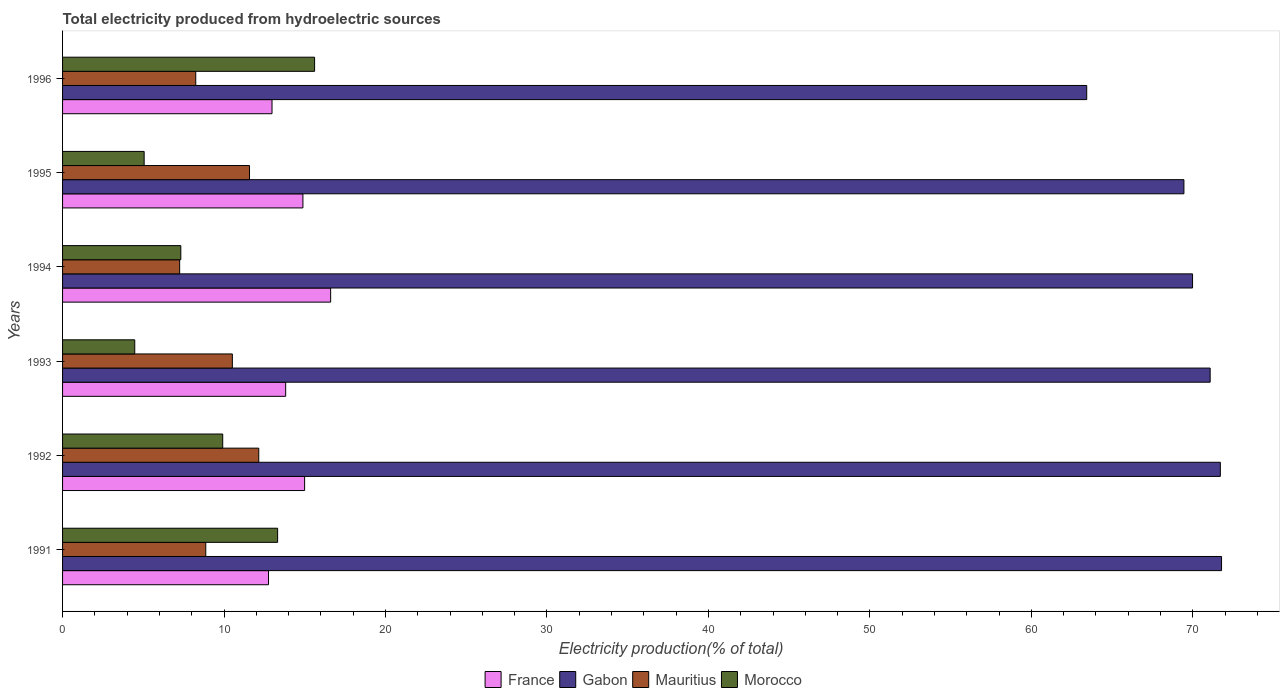How many different coloured bars are there?
Offer a terse response. 4. How many groups of bars are there?
Give a very brief answer. 6. Are the number of bars on each tick of the Y-axis equal?
Offer a terse response. Yes. How many bars are there on the 5th tick from the top?
Your response must be concise. 4. How many bars are there on the 3rd tick from the bottom?
Offer a terse response. 4. What is the total electricity produced in Mauritius in 1995?
Your answer should be compact. 11.58. Across all years, what is the maximum total electricity produced in Gabon?
Provide a short and direct response. 71.78. Across all years, what is the minimum total electricity produced in Morocco?
Keep it short and to the point. 4.47. In which year was the total electricity produced in France maximum?
Your response must be concise. 1994. What is the total total electricity produced in Morocco in the graph?
Offer a terse response. 55.69. What is the difference between the total electricity produced in Gabon in 1994 and that in 1995?
Offer a very short reply. 0.53. What is the difference between the total electricity produced in Morocco in 1994 and the total electricity produced in Gabon in 1991?
Your answer should be compact. -64.45. What is the average total electricity produced in Gabon per year?
Provide a succinct answer. 69.57. In the year 1994, what is the difference between the total electricity produced in Morocco and total electricity produced in Gabon?
Provide a succinct answer. -62.66. What is the ratio of the total electricity produced in Mauritius in 1991 to that in 1995?
Give a very brief answer. 0.77. Is the total electricity produced in Mauritius in 1994 less than that in 1995?
Make the answer very short. Yes. Is the difference between the total electricity produced in Morocco in 1992 and 1995 greater than the difference between the total electricity produced in Gabon in 1992 and 1995?
Make the answer very short. Yes. What is the difference between the highest and the second highest total electricity produced in France?
Make the answer very short. 1.61. What is the difference between the highest and the lowest total electricity produced in Gabon?
Provide a succinct answer. 8.35. Is the sum of the total electricity produced in Mauritius in 1991 and 1994 greater than the maximum total electricity produced in Gabon across all years?
Offer a very short reply. No. What does the 4th bar from the top in 1995 represents?
Offer a very short reply. France. What does the 4th bar from the bottom in 1996 represents?
Your answer should be compact. Morocco. Is it the case that in every year, the sum of the total electricity produced in Morocco and total electricity produced in Gabon is greater than the total electricity produced in Mauritius?
Your answer should be compact. Yes. Are all the bars in the graph horizontal?
Keep it short and to the point. Yes. Does the graph contain any zero values?
Make the answer very short. No. Does the graph contain grids?
Keep it short and to the point. No. Where does the legend appear in the graph?
Keep it short and to the point. Bottom center. What is the title of the graph?
Ensure brevity in your answer.  Total electricity produced from hydroelectric sources. What is the label or title of the X-axis?
Make the answer very short. Electricity production(% of total). What is the Electricity production(% of total) in France in 1991?
Your answer should be very brief. 12.75. What is the Electricity production(% of total) in Gabon in 1991?
Keep it short and to the point. 71.78. What is the Electricity production(% of total) in Mauritius in 1991?
Keep it short and to the point. 8.87. What is the Electricity production(% of total) of Morocco in 1991?
Provide a short and direct response. 13.32. What is the Electricity production(% of total) in France in 1992?
Provide a short and direct response. 14.99. What is the Electricity production(% of total) in Gabon in 1992?
Provide a succinct answer. 71.7. What is the Electricity production(% of total) of Mauritius in 1992?
Provide a short and direct response. 12.15. What is the Electricity production(% of total) of Morocco in 1992?
Your response must be concise. 9.92. What is the Electricity production(% of total) in France in 1993?
Give a very brief answer. 13.82. What is the Electricity production(% of total) in Gabon in 1993?
Provide a short and direct response. 71.07. What is the Electricity production(% of total) in Mauritius in 1993?
Ensure brevity in your answer.  10.52. What is the Electricity production(% of total) of Morocco in 1993?
Keep it short and to the point. 4.47. What is the Electricity production(% of total) in France in 1994?
Provide a short and direct response. 16.6. What is the Electricity production(% of total) in Gabon in 1994?
Offer a very short reply. 69.98. What is the Electricity production(% of total) in Mauritius in 1994?
Your answer should be very brief. 7.25. What is the Electricity production(% of total) of Morocco in 1994?
Provide a short and direct response. 7.32. What is the Electricity production(% of total) of France in 1995?
Keep it short and to the point. 14.89. What is the Electricity production(% of total) in Gabon in 1995?
Your response must be concise. 69.45. What is the Electricity production(% of total) in Mauritius in 1995?
Your response must be concise. 11.58. What is the Electricity production(% of total) of Morocco in 1995?
Keep it short and to the point. 5.05. What is the Electricity production(% of total) in France in 1996?
Ensure brevity in your answer.  12.97. What is the Electricity production(% of total) in Gabon in 1996?
Provide a succinct answer. 63.43. What is the Electricity production(% of total) of Mauritius in 1996?
Provide a short and direct response. 8.25. What is the Electricity production(% of total) in Morocco in 1996?
Offer a terse response. 15.61. Across all years, what is the maximum Electricity production(% of total) of France?
Offer a very short reply. 16.6. Across all years, what is the maximum Electricity production(% of total) in Gabon?
Provide a succinct answer. 71.78. Across all years, what is the maximum Electricity production(% of total) in Mauritius?
Your answer should be compact. 12.15. Across all years, what is the maximum Electricity production(% of total) of Morocco?
Provide a short and direct response. 15.61. Across all years, what is the minimum Electricity production(% of total) in France?
Keep it short and to the point. 12.75. Across all years, what is the minimum Electricity production(% of total) in Gabon?
Provide a short and direct response. 63.43. Across all years, what is the minimum Electricity production(% of total) in Mauritius?
Offer a very short reply. 7.25. Across all years, what is the minimum Electricity production(% of total) of Morocco?
Your answer should be very brief. 4.47. What is the total Electricity production(% of total) in France in the graph?
Provide a succinct answer. 86.02. What is the total Electricity production(% of total) of Gabon in the graph?
Provide a succinct answer. 417.4. What is the total Electricity production(% of total) of Mauritius in the graph?
Your response must be concise. 58.61. What is the total Electricity production(% of total) in Morocco in the graph?
Your response must be concise. 55.69. What is the difference between the Electricity production(% of total) in France in 1991 and that in 1992?
Offer a terse response. -2.24. What is the difference between the Electricity production(% of total) in Gabon in 1991 and that in 1992?
Your answer should be very brief. 0.07. What is the difference between the Electricity production(% of total) of Mauritius in 1991 and that in 1992?
Provide a succinct answer. -3.28. What is the difference between the Electricity production(% of total) of Morocco in 1991 and that in 1992?
Provide a succinct answer. 3.4. What is the difference between the Electricity production(% of total) in France in 1991 and that in 1993?
Provide a succinct answer. -1.06. What is the difference between the Electricity production(% of total) in Gabon in 1991 and that in 1993?
Provide a short and direct response. 0.71. What is the difference between the Electricity production(% of total) of Mauritius in 1991 and that in 1993?
Your answer should be very brief. -1.65. What is the difference between the Electricity production(% of total) of Morocco in 1991 and that in 1993?
Your response must be concise. 8.85. What is the difference between the Electricity production(% of total) of France in 1991 and that in 1994?
Give a very brief answer. -3.85. What is the difference between the Electricity production(% of total) in Gabon in 1991 and that in 1994?
Ensure brevity in your answer.  1.8. What is the difference between the Electricity production(% of total) in Mauritius in 1991 and that in 1994?
Provide a succinct answer. 1.62. What is the difference between the Electricity production(% of total) in Morocco in 1991 and that in 1994?
Your answer should be compact. 6. What is the difference between the Electricity production(% of total) of France in 1991 and that in 1995?
Make the answer very short. -2.13. What is the difference between the Electricity production(% of total) in Gabon in 1991 and that in 1995?
Your answer should be compact. 2.33. What is the difference between the Electricity production(% of total) in Mauritius in 1991 and that in 1995?
Offer a terse response. -2.71. What is the difference between the Electricity production(% of total) of Morocco in 1991 and that in 1995?
Give a very brief answer. 8.27. What is the difference between the Electricity production(% of total) in France in 1991 and that in 1996?
Make the answer very short. -0.22. What is the difference between the Electricity production(% of total) in Gabon in 1991 and that in 1996?
Ensure brevity in your answer.  8.35. What is the difference between the Electricity production(% of total) in Mauritius in 1991 and that in 1996?
Ensure brevity in your answer.  0.62. What is the difference between the Electricity production(% of total) of Morocco in 1991 and that in 1996?
Ensure brevity in your answer.  -2.29. What is the difference between the Electricity production(% of total) in France in 1992 and that in 1993?
Offer a very short reply. 1.17. What is the difference between the Electricity production(% of total) of Gabon in 1992 and that in 1993?
Offer a very short reply. 0.63. What is the difference between the Electricity production(% of total) of Mauritius in 1992 and that in 1993?
Your response must be concise. 1.63. What is the difference between the Electricity production(% of total) of Morocco in 1992 and that in 1993?
Ensure brevity in your answer.  5.45. What is the difference between the Electricity production(% of total) of France in 1992 and that in 1994?
Your answer should be very brief. -1.61. What is the difference between the Electricity production(% of total) of Gabon in 1992 and that in 1994?
Your answer should be very brief. 1.72. What is the difference between the Electricity production(% of total) in Mauritius in 1992 and that in 1994?
Offer a terse response. 4.9. What is the difference between the Electricity production(% of total) in Morocco in 1992 and that in 1994?
Your response must be concise. 2.6. What is the difference between the Electricity production(% of total) in France in 1992 and that in 1995?
Your response must be concise. 0.1. What is the difference between the Electricity production(% of total) in Gabon in 1992 and that in 1995?
Make the answer very short. 2.25. What is the difference between the Electricity production(% of total) in Mauritius in 1992 and that in 1995?
Offer a terse response. 0.57. What is the difference between the Electricity production(% of total) in Morocco in 1992 and that in 1995?
Your answer should be very brief. 4.87. What is the difference between the Electricity production(% of total) of France in 1992 and that in 1996?
Provide a short and direct response. 2.02. What is the difference between the Electricity production(% of total) of Gabon in 1992 and that in 1996?
Your response must be concise. 8.28. What is the difference between the Electricity production(% of total) in Mauritius in 1992 and that in 1996?
Ensure brevity in your answer.  3.9. What is the difference between the Electricity production(% of total) in Morocco in 1992 and that in 1996?
Keep it short and to the point. -5.69. What is the difference between the Electricity production(% of total) in France in 1993 and that in 1994?
Offer a terse response. -2.78. What is the difference between the Electricity production(% of total) in Gabon in 1993 and that in 1994?
Your response must be concise. 1.09. What is the difference between the Electricity production(% of total) in Mauritius in 1993 and that in 1994?
Provide a succinct answer. 3.26. What is the difference between the Electricity production(% of total) of Morocco in 1993 and that in 1994?
Your answer should be very brief. -2.85. What is the difference between the Electricity production(% of total) of France in 1993 and that in 1995?
Your answer should be very brief. -1.07. What is the difference between the Electricity production(% of total) in Gabon in 1993 and that in 1995?
Give a very brief answer. 1.62. What is the difference between the Electricity production(% of total) in Mauritius in 1993 and that in 1995?
Your answer should be very brief. -1.06. What is the difference between the Electricity production(% of total) of Morocco in 1993 and that in 1995?
Keep it short and to the point. -0.58. What is the difference between the Electricity production(% of total) of France in 1993 and that in 1996?
Keep it short and to the point. 0.85. What is the difference between the Electricity production(% of total) in Gabon in 1993 and that in 1996?
Your answer should be compact. 7.64. What is the difference between the Electricity production(% of total) in Mauritius in 1993 and that in 1996?
Your answer should be compact. 2.27. What is the difference between the Electricity production(% of total) in Morocco in 1993 and that in 1996?
Offer a very short reply. -11.14. What is the difference between the Electricity production(% of total) of France in 1994 and that in 1995?
Your response must be concise. 1.72. What is the difference between the Electricity production(% of total) of Gabon in 1994 and that in 1995?
Offer a terse response. 0.53. What is the difference between the Electricity production(% of total) in Mauritius in 1994 and that in 1995?
Make the answer very short. -4.33. What is the difference between the Electricity production(% of total) of Morocco in 1994 and that in 1995?
Offer a very short reply. 2.27. What is the difference between the Electricity production(% of total) of France in 1994 and that in 1996?
Make the answer very short. 3.63. What is the difference between the Electricity production(% of total) of Gabon in 1994 and that in 1996?
Offer a terse response. 6.55. What is the difference between the Electricity production(% of total) in Mauritius in 1994 and that in 1996?
Your answer should be compact. -1. What is the difference between the Electricity production(% of total) in Morocco in 1994 and that in 1996?
Your answer should be very brief. -8.29. What is the difference between the Electricity production(% of total) in France in 1995 and that in 1996?
Provide a succinct answer. 1.91. What is the difference between the Electricity production(% of total) of Gabon in 1995 and that in 1996?
Offer a terse response. 6.02. What is the difference between the Electricity production(% of total) in Mauritius in 1995 and that in 1996?
Offer a very short reply. 3.33. What is the difference between the Electricity production(% of total) in Morocco in 1995 and that in 1996?
Keep it short and to the point. -10.56. What is the difference between the Electricity production(% of total) of France in 1991 and the Electricity production(% of total) of Gabon in 1992?
Give a very brief answer. -58.95. What is the difference between the Electricity production(% of total) of France in 1991 and the Electricity production(% of total) of Mauritius in 1992?
Provide a succinct answer. 0.6. What is the difference between the Electricity production(% of total) in France in 1991 and the Electricity production(% of total) in Morocco in 1992?
Keep it short and to the point. 2.84. What is the difference between the Electricity production(% of total) in Gabon in 1991 and the Electricity production(% of total) in Mauritius in 1992?
Make the answer very short. 59.63. What is the difference between the Electricity production(% of total) in Gabon in 1991 and the Electricity production(% of total) in Morocco in 1992?
Keep it short and to the point. 61.86. What is the difference between the Electricity production(% of total) in Mauritius in 1991 and the Electricity production(% of total) in Morocco in 1992?
Provide a short and direct response. -1.05. What is the difference between the Electricity production(% of total) in France in 1991 and the Electricity production(% of total) in Gabon in 1993?
Give a very brief answer. -58.32. What is the difference between the Electricity production(% of total) of France in 1991 and the Electricity production(% of total) of Mauritius in 1993?
Your answer should be compact. 2.24. What is the difference between the Electricity production(% of total) in France in 1991 and the Electricity production(% of total) in Morocco in 1993?
Offer a terse response. 8.28. What is the difference between the Electricity production(% of total) in Gabon in 1991 and the Electricity production(% of total) in Mauritius in 1993?
Your response must be concise. 61.26. What is the difference between the Electricity production(% of total) in Gabon in 1991 and the Electricity production(% of total) in Morocco in 1993?
Your response must be concise. 67.31. What is the difference between the Electricity production(% of total) of Mauritius in 1991 and the Electricity production(% of total) of Morocco in 1993?
Provide a short and direct response. 4.4. What is the difference between the Electricity production(% of total) of France in 1991 and the Electricity production(% of total) of Gabon in 1994?
Make the answer very short. -57.23. What is the difference between the Electricity production(% of total) in France in 1991 and the Electricity production(% of total) in Mauritius in 1994?
Make the answer very short. 5.5. What is the difference between the Electricity production(% of total) of France in 1991 and the Electricity production(% of total) of Morocco in 1994?
Offer a very short reply. 5.43. What is the difference between the Electricity production(% of total) of Gabon in 1991 and the Electricity production(% of total) of Mauritius in 1994?
Give a very brief answer. 64.52. What is the difference between the Electricity production(% of total) in Gabon in 1991 and the Electricity production(% of total) in Morocco in 1994?
Your response must be concise. 64.45. What is the difference between the Electricity production(% of total) in Mauritius in 1991 and the Electricity production(% of total) in Morocco in 1994?
Offer a very short reply. 1.54. What is the difference between the Electricity production(% of total) of France in 1991 and the Electricity production(% of total) of Gabon in 1995?
Make the answer very short. -56.69. What is the difference between the Electricity production(% of total) in France in 1991 and the Electricity production(% of total) in Mauritius in 1995?
Offer a very short reply. 1.18. What is the difference between the Electricity production(% of total) in France in 1991 and the Electricity production(% of total) in Morocco in 1995?
Keep it short and to the point. 7.7. What is the difference between the Electricity production(% of total) of Gabon in 1991 and the Electricity production(% of total) of Mauritius in 1995?
Provide a succinct answer. 60.2. What is the difference between the Electricity production(% of total) of Gabon in 1991 and the Electricity production(% of total) of Morocco in 1995?
Offer a very short reply. 66.72. What is the difference between the Electricity production(% of total) in Mauritius in 1991 and the Electricity production(% of total) in Morocco in 1995?
Provide a short and direct response. 3.82. What is the difference between the Electricity production(% of total) in France in 1991 and the Electricity production(% of total) in Gabon in 1996?
Your response must be concise. -50.67. What is the difference between the Electricity production(% of total) of France in 1991 and the Electricity production(% of total) of Mauritius in 1996?
Provide a succinct answer. 4.51. What is the difference between the Electricity production(% of total) of France in 1991 and the Electricity production(% of total) of Morocco in 1996?
Provide a succinct answer. -2.85. What is the difference between the Electricity production(% of total) in Gabon in 1991 and the Electricity production(% of total) in Mauritius in 1996?
Your answer should be compact. 63.53. What is the difference between the Electricity production(% of total) of Gabon in 1991 and the Electricity production(% of total) of Morocco in 1996?
Keep it short and to the point. 56.17. What is the difference between the Electricity production(% of total) in Mauritius in 1991 and the Electricity production(% of total) in Morocco in 1996?
Provide a succinct answer. -6.74. What is the difference between the Electricity production(% of total) of France in 1992 and the Electricity production(% of total) of Gabon in 1993?
Offer a very short reply. -56.08. What is the difference between the Electricity production(% of total) in France in 1992 and the Electricity production(% of total) in Mauritius in 1993?
Your answer should be compact. 4.47. What is the difference between the Electricity production(% of total) of France in 1992 and the Electricity production(% of total) of Morocco in 1993?
Keep it short and to the point. 10.52. What is the difference between the Electricity production(% of total) of Gabon in 1992 and the Electricity production(% of total) of Mauritius in 1993?
Offer a very short reply. 61.19. What is the difference between the Electricity production(% of total) in Gabon in 1992 and the Electricity production(% of total) in Morocco in 1993?
Offer a very short reply. 67.23. What is the difference between the Electricity production(% of total) in Mauritius in 1992 and the Electricity production(% of total) in Morocco in 1993?
Give a very brief answer. 7.68. What is the difference between the Electricity production(% of total) of France in 1992 and the Electricity production(% of total) of Gabon in 1994?
Provide a short and direct response. -54.99. What is the difference between the Electricity production(% of total) of France in 1992 and the Electricity production(% of total) of Mauritius in 1994?
Your answer should be compact. 7.74. What is the difference between the Electricity production(% of total) in France in 1992 and the Electricity production(% of total) in Morocco in 1994?
Make the answer very short. 7.67. What is the difference between the Electricity production(% of total) of Gabon in 1992 and the Electricity production(% of total) of Mauritius in 1994?
Offer a terse response. 64.45. What is the difference between the Electricity production(% of total) of Gabon in 1992 and the Electricity production(% of total) of Morocco in 1994?
Ensure brevity in your answer.  64.38. What is the difference between the Electricity production(% of total) in Mauritius in 1992 and the Electricity production(% of total) in Morocco in 1994?
Your response must be concise. 4.83. What is the difference between the Electricity production(% of total) of France in 1992 and the Electricity production(% of total) of Gabon in 1995?
Keep it short and to the point. -54.46. What is the difference between the Electricity production(% of total) of France in 1992 and the Electricity production(% of total) of Mauritius in 1995?
Provide a short and direct response. 3.41. What is the difference between the Electricity production(% of total) of France in 1992 and the Electricity production(% of total) of Morocco in 1995?
Offer a very short reply. 9.94. What is the difference between the Electricity production(% of total) of Gabon in 1992 and the Electricity production(% of total) of Mauritius in 1995?
Keep it short and to the point. 60.12. What is the difference between the Electricity production(% of total) of Gabon in 1992 and the Electricity production(% of total) of Morocco in 1995?
Provide a short and direct response. 66.65. What is the difference between the Electricity production(% of total) in Mauritius in 1992 and the Electricity production(% of total) in Morocco in 1995?
Provide a short and direct response. 7.1. What is the difference between the Electricity production(% of total) in France in 1992 and the Electricity production(% of total) in Gabon in 1996?
Provide a succinct answer. -48.44. What is the difference between the Electricity production(% of total) of France in 1992 and the Electricity production(% of total) of Mauritius in 1996?
Offer a terse response. 6.74. What is the difference between the Electricity production(% of total) of France in 1992 and the Electricity production(% of total) of Morocco in 1996?
Make the answer very short. -0.62. What is the difference between the Electricity production(% of total) in Gabon in 1992 and the Electricity production(% of total) in Mauritius in 1996?
Your answer should be compact. 63.45. What is the difference between the Electricity production(% of total) of Gabon in 1992 and the Electricity production(% of total) of Morocco in 1996?
Provide a short and direct response. 56.09. What is the difference between the Electricity production(% of total) of Mauritius in 1992 and the Electricity production(% of total) of Morocco in 1996?
Provide a short and direct response. -3.46. What is the difference between the Electricity production(% of total) of France in 1993 and the Electricity production(% of total) of Gabon in 1994?
Give a very brief answer. -56.16. What is the difference between the Electricity production(% of total) in France in 1993 and the Electricity production(% of total) in Mauritius in 1994?
Make the answer very short. 6.57. What is the difference between the Electricity production(% of total) of France in 1993 and the Electricity production(% of total) of Morocco in 1994?
Keep it short and to the point. 6.49. What is the difference between the Electricity production(% of total) in Gabon in 1993 and the Electricity production(% of total) in Mauritius in 1994?
Provide a succinct answer. 63.82. What is the difference between the Electricity production(% of total) in Gabon in 1993 and the Electricity production(% of total) in Morocco in 1994?
Offer a terse response. 63.75. What is the difference between the Electricity production(% of total) in Mauritius in 1993 and the Electricity production(% of total) in Morocco in 1994?
Provide a short and direct response. 3.19. What is the difference between the Electricity production(% of total) of France in 1993 and the Electricity production(% of total) of Gabon in 1995?
Provide a succinct answer. -55.63. What is the difference between the Electricity production(% of total) in France in 1993 and the Electricity production(% of total) in Mauritius in 1995?
Offer a very short reply. 2.24. What is the difference between the Electricity production(% of total) of France in 1993 and the Electricity production(% of total) of Morocco in 1995?
Offer a very short reply. 8.76. What is the difference between the Electricity production(% of total) in Gabon in 1993 and the Electricity production(% of total) in Mauritius in 1995?
Provide a succinct answer. 59.49. What is the difference between the Electricity production(% of total) in Gabon in 1993 and the Electricity production(% of total) in Morocco in 1995?
Offer a very short reply. 66.02. What is the difference between the Electricity production(% of total) of Mauritius in 1993 and the Electricity production(% of total) of Morocco in 1995?
Your response must be concise. 5.46. What is the difference between the Electricity production(% of total) of France in 1993 and the Electricity production(% of total) of Gabon in 1996?
Offer a terse response. -49.61. What is the difference between the Electricity production(% of total) of France in 1993 and the Electricity production(% of total) of Mauritius in 1996?
Your answer should be very brief. 5.57. What is the difference between the Electricity production(% of total) of France in 1993 and the Electricity production(% of total) of Morocco in 1996?
Ensure brevity in your answer.  -1.79. What is the difference between the Electricity production(% of total) of Gabon in 1993 and the Electricity production(% of total) of Mauritius in 1996?
Offer a terse response. 62.82. What is the difference between the Electricity production(% of total) of Gabon in 1993 and the Electricity production(% of total) of Morocco in 1996?
Offer a terse response. 55.46. What is the difference between the Electricity production(% of total) of Mauritius in 1993 and the Electricity production(% of total) of Morocco in 1996?
Provide a succinct answer. -5.09. What is the difference between the Electricity production(% of total) in France in 1994 and the Electricity production(% of total) in Gabon in 1995?
Ensure brevity in your answer.  -52.84. What is the difference between the Electricity production(% of total) in France in 1994 and the Electricity production(% of total) in Mauritius in 1995?
Provide a short and direct response. 5.02. What is the difference between the Electricity production(% of total) of France in 1994 and the Electricity production(% of total) of Morocco in 1995?
Ensure brevity in your answer.  11.55. What is the difference between the Electricity production(% of total) in Gabon in 1994 and the Electricity production(% of total) in Mauritius in 1995?
Give a very brief answer. 58.4. What is the difference between the Electricity production(% of total) in Gabon in 1994 and the Electricity production(% of total) in Morocco in 1995?
Your response must be concise. 64.93. What is the difference between the Electricity production(% of total) in Mauritius in 1994 and the Electricity production(% of total) in Morocco in 1995?
Your answer should be very brief. 2.2. What is the difference between the Electricity production(% of total) in France in 1994 and the Electricity production(% of total) in Gabon in 1996?
Give a very brief answer. -46.82. What is the difference between the Electricity production(% of total) in France in 1994 and the Electricity production(% of total) in Mauritius in 1996?
Make the answer very short. 8.35. What is the difference between the Electricity production(% of total) of Gabon in 1994 and the Electricity production(% of total) of Mauritius in 1996?
Make the answer very short. 61.73. What is the difference between the Electricity production(% of total) of Gabon in 1994 and the Electricity production(% of total) of Morocco in 1996?
Make the answer very short. 54.37. What is the difference between the Electricity production(% of total) of Mauritius in 1994 and the Electricity production(% of total) of Morocco in 1996?
Make the answer very short. -8.36. What is the difference between the Electricity production(% of total) of France in 1995 and the Electricity production(% of total) of Gabon in 1996?
Keep it short and to the point. -48.54. What is the difference between the Electricity production(% of total) in France in 1995 and the Electricity production(% of total) in Mauritius in 1996?
Offer a very short reply. 6.64. What is the difference between the Electricity production(% of total) of France in 1995 and the Electricity production(% of total) of Morocco in 1996?
Provide a succinct answer. -0.72. What is the difference between the Electricity production(% of total) of Gabon in 1995 and the Electricity production(% of total) of Mauritius in 1996?
Offer a very short reply. 61.2. What is the difference between the Electricity production(% of total) of Gabon in 1995 and the Electricity production(% of total) of Morocco in 1996?
Ensure brevity in your answer.  53.84. What is the difference between the Electricity production(% of total) in Mauritius in 1995 and the Electricity production(% of total) in Morocco in 1996?
Your answer should be compact. -4.03. What is the average Electricity production(% of total) in France per year?
Your response must be concise. 14.34. What is the average Electricity production(% of total) in Gabon per year?
Provide a short and direct response. 69.57. What is the average Electricity production(% of total) of Mauritius per year?
Make the answer very short. 9.77. What is the average Electricity production(% of total) in Morocco per year?
Your answer should be compact. 9.28. In the year 1991, what is the difference between the Electricity production(% of total) in France and Electricity production(% of total) in Gabon?
Provide a short and direct response. -59.02. In the year 1991, what is the difference between the Electricity production(% of total) of France and Electricity production(% of total) of Mauritius?
Provide a short and direct response. 3.89. In the year 1991, what is the difference between the Electricity production(% of total) of France and Electricity production(% of total) of Morocco?
Ensure brevity in your answer.  -0.56. In the year 1991, what is the difference between the Electricity production(% of total) of Gabon and Electricity production(% of total) of Mauritius?
Ensure brevity in your answer.  62.91. In the year 1991, what is the difference between the Electricity production(% of total) in Gabon and Electricity production(% of total) in Morocco?
Your answer should be very brief. 58.46. In the year 1991, what is the difference between the Electricity production(% of total) of Mauritius and Electricity production(% of total) of Morocco?
Give a very brief answer. -4.45. In the year 1992, what is the difference between the Electricity production(% of total) of France and Electricity production(% of total) of Gabon?
Give a very brief answer. -56.71. In the year 1992, what is the difference between the Electricity production(% of total) in France and Electricity production(% of total) in Mauritius?
Provide a short and direct response. 2.84. In the year 1992, what is the difference between the Electricity production(% of total) in France and Electricity production(% of total) in Morocco?
Provide a short and direct response. 5.07. In the year 1992, what is the difference between the Electricity production(% of total) in Gabon and Electricity production(% of total) in Mauritius?
Offer a very short reply. 59.55. In the year 1992, what is the difference between the Electricity production(% of total) of Gabon and Electricity production(% of total) of Morocco?
Provide a succinct answer. 61.78. In the year 1992, what is the difference between the Electricity production(% of total) in Mauritius and Electricity production(% of total) in Morocco?
Offer a terse response. 2.23. In the year 1993, what is the difference between the Electricity production(% of total) of France and Electricity production(% of total) of Gabon?
Give a very brief answer. -57.25. In the year 1993, what is the difference between the Electricity production(% of total) in France and Electricity production(% of total) in Mauritius?
Ensure brevity in your answer.  3.3. In the year 1993, what is the difference between the Electricity production(% of total) of France and Electricity production(% of total) of Morocco?
Give a very brief answer. 9.35. In the year 1993, what is the difference between the Electricity production(% of total) of Gabon and Electricity production(% of total) of Mauritius?
Provide a succinct answer. 60.56. In the year 1993, what is the difference between the Electricity production(% of total) in Gabon and Electricity production(% of total) in Morocco?
Offer a very short reply. 66.6. In the year 1993, what is the difference between the Electricity production(% of total) of Mauritius and Electricity production(% of total) of Morocco?
Give a very brief answer. 6.05. In the year 1994, what is the difference between the Electricity production(% of total) of France and Electricity production(% of total) of Gabon?
Your answer should be compact. -53.38. In the year 1994, what is the difference between the Electricity production(% of total) of France and Electricity production(% of total) of Mauritius?
Your answer should be very brief. 9.35. In the year 1994, what is the difference between the Electricity production(% of total) of France and Electricity production(% of total) of Morocco?
Offer a terse response. 9.28. In the year 1994, what is the difference between the Electricity production(% of total) in Gabon and Electricity production(% of total) in Mauritius?
Your answer should be compact. 62.73. In the year 1994, what is the difference between the Electricity production(% of total) of Gabon and Electricity production(% of total) of Morocco?
Your answer should be compact. 62.66. In the year 1994, what is the difference between the Electricity production(% of total) of Mauritius and Electricity production(% of total) of Morocco?
Keep it short and to the point. -0.07. In the year 1995, what is the difference between the Electricity production(% of total) in France and Electricity production(% of total) in Gabon?
Keep it short and to the point. -54.56. In the year 1995, what is the difference between the Electricity production(% of total) of France and Electricity production(% of total) of Mauritius?
Provide a succinct answer. 3.31. In the year 1995, what is the difference between the Electricity production(% of total) in France and Electricity production(% of total) in Morocco?
Your answer should be compact. 9.83. In the year 1995, what is the difference between the Electricity production(% of total) in Gabon and Electricity production(% of total) in Mauritius?
Make the answer very short. 57.87. In the year 1995, what is the difference between the Electricity production(% of total) of Gabon and Electricity production(% of total) of Morocco?
Provide a succinct answer. 64.39. In the year 1995, what is the difference between the Electricity production(% of total) in Mauritius and Electricity production(% of total) in Morocco?
Your response must be concise. 6.53. In the year 1996, what is the difference between the Electricity production(% of total) of France and Electricity production(% of total) of Gabon?
Give a very brief answer. -50.46. In the year 1996, what is the difference between the Electricity production(% of total) in France and Electricity production(% of total) in Mauritius?
Keep it short and to the point. 4.72. In the year 1996, what is the difference between the Electricity production(% of total) in France and Electricity production(% of total) in Morocco?
Ensure brevity in your answer.  -2.64. In the year 1996, what is the difference between the Electricity production(% of total) of Gabon and Electricity production(% of total) of Mauritius?
Your response must be concise. 55.18. In the year 1996, what is the difference between the Electricity production(% of total) in Gabon and Electricity production(% of total) in Morocco?
Offer a very short reply. 47.82. In the year 1996, what is the difference between the Electricity production(% of total) of Mauritius and Electricity production(% of total) of Morocco?
Offer a very short reply. -7.36. What is the ratio of the Electricity production(% of total) in France in 1991 to that in 1992?
Offer a very short reply. 0.85. What is the ratio of the Electricity production(% of total) of Mauritius in 1991 to that in 1992?
Offer a terse response. 0.73. What is the ratio of the Electricity production(% of total) of Morocco in 1991 to that in 1992?
Ensure brevity in your answer.  1.34. What is the ratio of the Electricity production(% of total) in Gabon in 1991 to that in 1993?
Provide a short and direct response. 1.01. What is the ratio of the Electricity production(% of total) in Mauritius in 1991 to that in 1993?
Give a very brief answer. 0.84. What is the ratio of the Electricity production(% of total) of Morocco in 1991 to that in 1993?
Offer a terse response. 2.98. What is the ratio of the Electricity production(% of total) of France in 1991 to that in 1994?
Keep it short and to the point. 0.77. What is the ratio of the Electricity production(% of total) in Gabon in 1991 to that in 1994?
Your answer should be compact. 1.03. What is the ratio of the Electricity production(% of total) in Mauritius in 1991 to that in 1994?
Keep it short and to the point. 1.22. What is the ratio of the Electricity production(% of total) in Morocco in 1991 to that in 1994?
Make the answer very short. 1.82. What is the ratio of the Electricity production(% of total) in France in 1991 to that in 1995?
Ensure brevity in your answer.  0.86. What is the ratio of the Electricity production(% of total) of Gabon in 1991 to that in 1995?
Give a very brief answer. 1.03. What is the ratio of the Electricity production(% of total) of Mauritius in 1991 to that in 1995?
Offer a terse response. 0.77. What is the ratio of the Electricity production(% of total) in Morocco in 1991 to that in 1995?
Offer a very short reply. 2.64. What is the ratio of the Electricity production(% of total) of France in 1991 to that in 1996?
Keep it short and to the point. 0.98. What is the ratio of the Electricity production(% of total) in Gabon in 1991 to that in 1996?
Offer a very short reply. 1.13. What is the ratio of the Electricity production(% of total) in Mauritius in 1991 to that in 1996?
Ensure brevity in your answer.  1.08. What is the ratio of the Electricity production(% of total) in Morocco in 1991 to that in 1996?
Provide a short and direct response. 0.85. What is the ratio of the Electricity production(% of total) in France in 1992 to that in 1993?
Your response must be concise. 1.08. What is the ratio of the Electricity production(% of total) in Gabon in 1992 to that in 1993?
Ensure brevity in your answer.  1.01. What is the ratio of the Electricity production(% of total) of Mauritius in 1992 to that in 1993?
Your answer should be very brief. 1.16. What is the ratio of the Electricity production(% of total) in Morocco in 1992 to that in 1993?
Give a very brief answer. 2.22. What is the ratio of the Electricity production(% of total) of France in 1992 to that in 1994?
Keep it short and to the point. 0.9. What is the ratio of the Electricity production(% of total) of Gabon in 1992 to that in 1994?
Your answer should be compact. 1.02. What is the ratio of the Electricity production(% of total) in Mauritius in 1992 to that in 1994?
Provide a short and direct response. 1.68. What is the ratio of the Electricity production(% of total) in Morocco in 1992 to that in 1994?
Provide a succinct answer. 1.35. What is the ratio of the Electricity production(% of total) in France in 1992 to that in 1995?
Give a very brief answer. 1.01. What is the ratio of the Electricity production(% of total) of Gabon in 1992 to that in 1995?
Provide a succinct answer. 1.03. What is the ratio of the Electricity production(% of total) of Mauritius in 1992 to that in 1995?
Your answer should be compact. 1.05. What is the ratio of the Electricity production(% of total) in Morocco in 1992 to that in 1995?
Offer a very short reply. 1.96. What is the ratio of the Electricity production(% of total) in France in 1992 to that in 1996?
Make the answer very short. 1.16. What is the ratio of the Electricity production(% of total) in Gabon in 1992 to that in 1996?
Your response must be concise. 1.13. What is the ratio of the Electricity production(% of total) of Mauritius in 1992 to that in 1996?
Provide a succinct answer. 1.47. What is the ratio of the Electricity production(% of total) of Morocco in 1992 to that in 1996?
Offer a terse response. 0.64. What is the ratio of the Electricity production(% of total) in France in 1993 to that in 1994?
Your answer should be compact. 0.83. What is the ratio of the Electricity production(% of total) in Gabon in 1993 to that in 1994?
Offer a very short reply. 1.02. What is the ratio of the Electricity production(% of total) in Mauritius in 1993 to that in 1994?
Keep it short and to the point. 1.45. What is the ratio of the Electricity production(% of total) in Morocco in 1993 to that in 1994?
Provide a short and direct response. 0.61. What is the ratio of the Electricity production(% of total) of France in 1993 to that in 1995?
Make the answer very short. 0.93. What is the ratio of the Electricity production(% of total) of Gabon in 1993 to that in 1995?
Provide a succinct answer. 1.02. What is the ratio of the Electricity production(% of total) in Mauritius in 1993 to that in 1995?
Keep it short and to the point. 0.91. What is the ratio of the Electricity production(% of total) of Morocco in 1993 to that in 1995?
Make the answer very short. 0.88. What is the ratio of the Electricity production(% of total) in France in 1993 to that in 1996?
Give a very brief answer. 1.07. What is the ratio of the Electricity production(% of total) of Gabon in 1993 to that in 1996?
Keep it short and to the point. 1.12. What is the ratio of the Electricity production(% of total) of Mauritius in 1993 to that in 1996?
Give a very brief answer. 1.27. What is the ratio of the Electricity production(% of total) in Morocco in 1993 to that in 1996?
Provide a succinct answer. 0.29. What is the ratio of the Electricity production(% of total) of France in 1994 to that in 1995?
Provide a short and direct response. 1.12. What is the ratio of the Electricity production(% of total) in Gabon in 1994 to that in 1995?
Your answer should be compact. 1.01. What is the ratio of the Electricity production(% of total) of Mauritius in 1994 to that in 1995?
Offer a terse response. 0.63. What is the ratio of the Electricity production(% of total) in Morocco in 1994 to that in 1995?
Offer a very short reply. 1.45. What is the ratio of the Electricity production(% of total) of France in 1994 to that in 1996?
Offer a very short reply. 1.28. What is the ratio of the Electricity production(% of total) in Gabon in 1994 to that in 1996?
Give a very brief answer. 1.1. What is the ratio of the Electricity production(% of total) in Mauritius in 1994 to that in 1996?
Your answer should be compact. 0.88. What is the ratio of the Electricity production(% of total) in Morocco in 1994 to that in 1996?
Provide a short and direct response. 0.47. What is the ratio of the Electricity production(% of total) of France in 1995 to that in 1996?
Make the answer very short. 1.15. What is the ratio of the Electricity production(% of total) in Gabon in 1995 to that in 1996?
Your response must be concise. 1.09. What is the ratio of the Electricity production(% of total) of Mauritius in 1995 to that in 1996?
Offer a terse response. 1.4. What is the ratio of the Electricity production(% of total) of Morocco in 1995 to that in 1996?
Your answer should be compact. 0.32. What is the difference between the highest and the second highest Electricity production(% of total) in France?
Offer a very short reply. 1.61. What is the difference between the highest and the second highest Electricity production(% of total) in Gabon?
Your answer should be compact. 0.07. What is the difference between the highest and the second highest Electricity production(% of total) in Mauritius?
Ensure brevity in your answer.  0.57. What is the difference between the highest and the second highest Electricity production(% of total) in Morocco?
Provide a short and direct response. 2.29. What is the difference between the highest and the lowest Electricity production(% of total) in France?
Provide a short and direct response. 3.85. What is the difference between the highest and the lowest Electricity production(% of total) of Gabon?
Ensure brevity in your answer.  8.35. What is the difference between the highest and the lowest Electricity production(% of total) in Mauritius?
Your response must be concise. 4.9. What is the difference between the highest and the lowest Electricity production(% of total) of Morocco?
Provide a short and direct response. 11.14. 